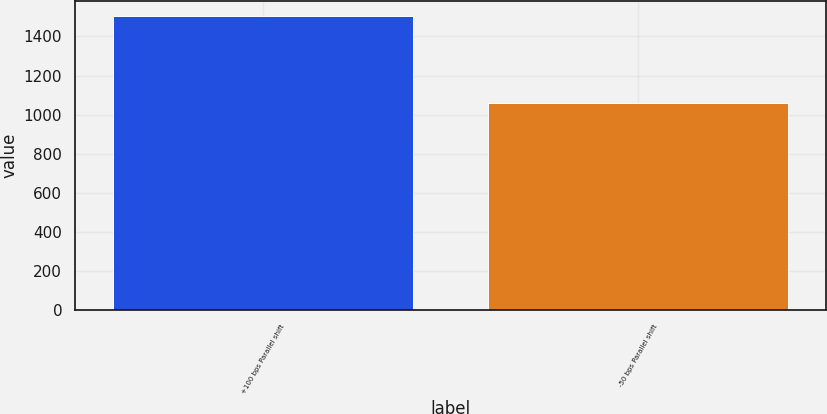Convert chart to OTSL. <chart><loc_0><loc_0><loc_500><loc_500><bar_chart><fcel>+100 bps Parallel shift<fcel>-50 bps Parallel shift<nl><fcel>1505<fcel>1061<nl></chart> 